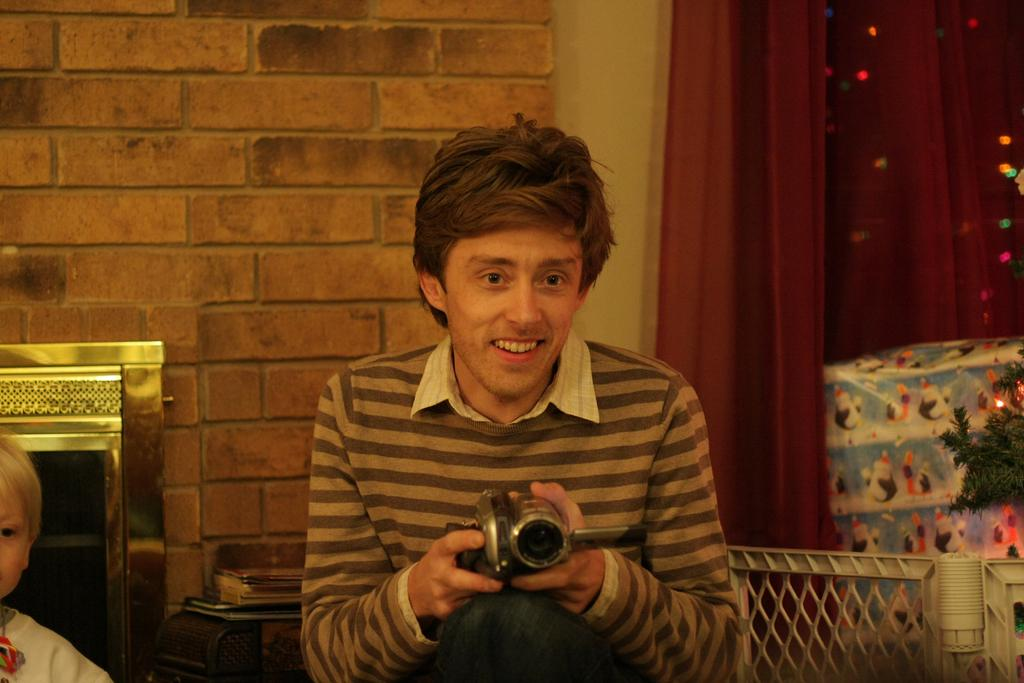What is the man in the image holding? The man is holding a camera in the image. Where is the man located in the image? The man is on the left side of the image. What can be seen in the background of the image? There is a child, a wall, a curtain, and a tree in the background of the image. What type of soup is being served on top of the tree in the image? There is no soup or tree present in the image; it only features a man holding a camera and various background elements. 